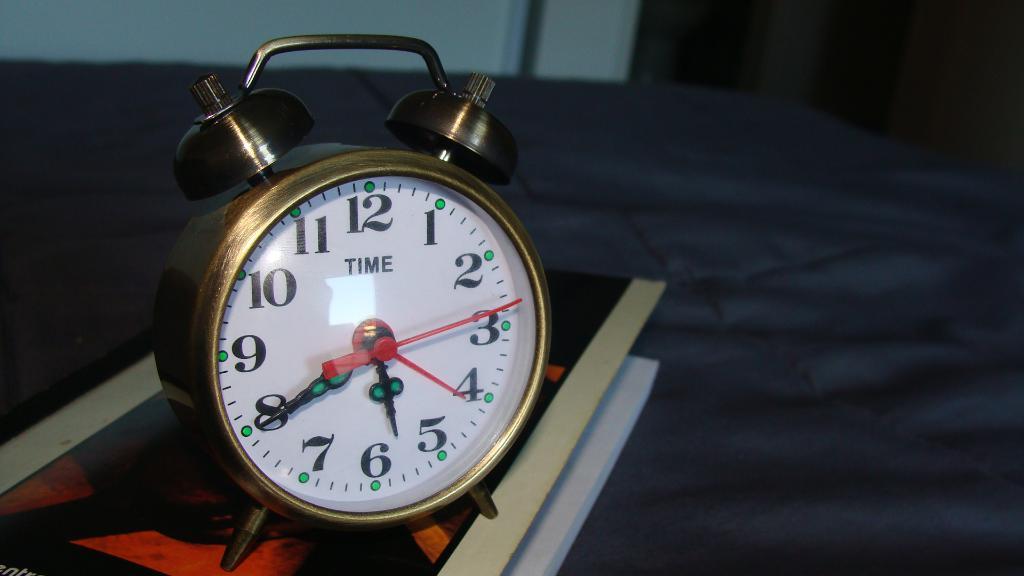What time is it?
Provide a short and direct response. 5:40. What is written abovew the center of the clock?
Your answer should be compact. Time. 